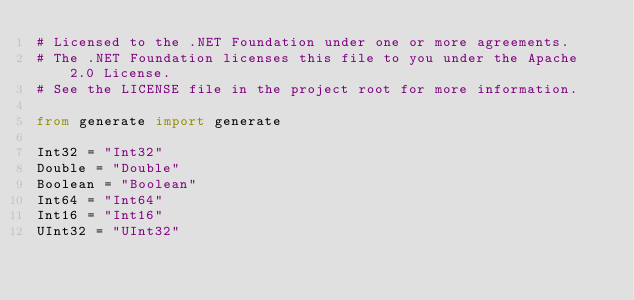Convert code to text. <code><loc_0><loc_0><loc_500><loc_500><_Python_># Licensed to the .NET Foundation under one or more agreements.
# The .NET Foundation licenses this file to you under the Apache 2.0 License.
# See the LICENSE file in the project root for more information.

from generate import generate

Int32 = "Int32"
Double = "Double"
Boolean = "Boolean"
Int64 = "Int64"
Int16 = "Int16"
UInt32 = "UInt32"</code> 